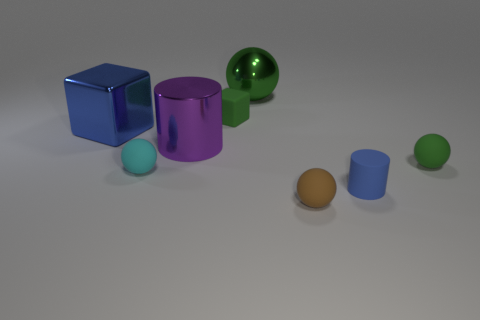Add 1 matte cylinders. How many objects exist? 9 Subtract all cylinders. How many objects are left? 6 Subtract all cyan matte balls. Subtract all tiny things. How many objects are left? 2 Add 2 tiny blue cylinders. How many tiny blue cylinders are left? 3 Add 6 tiny green matte objects. How many tiny green matte objects exist? 8 Subtract 0 red cylinders. How many objects are left? 8 